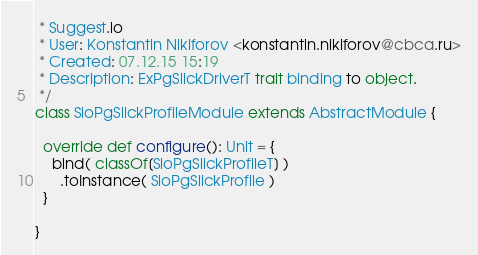<code> <loc_0><loc_0><loc_500><loc_500><_Scala_> * Suggest.io
 * User: Konstantin Nikiforov <konstantin.nikiforov@cbca.ru>
 * Created: 07.12.15 15:19
 * Description: ExPgSlickDriverT trait binding to object.
 */
class SioPgSlickProfileModule extends AbstractModule {

  override def configure(): Unit = {
    bind( classOf[SioPgSlickProfileT] )
      .toInstance( SioPgSlickProfile )
  }

}
</code> 